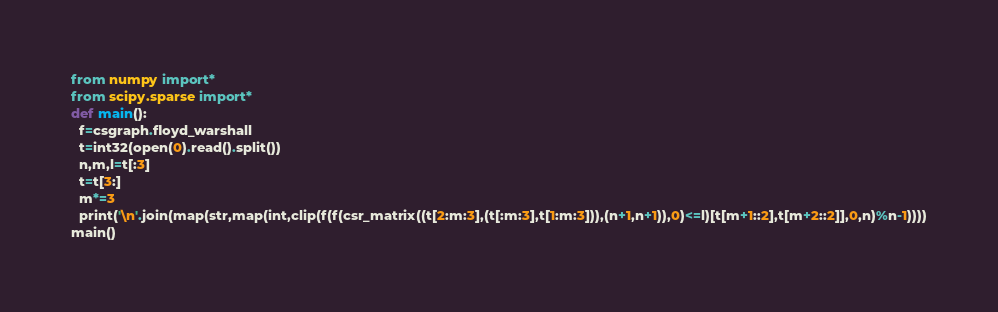Convert code to text. <code><loc_0><loc_0><loc_500><loc_500><_Python_>from numpy import*
from scipy.sparse import*
def main():
  f=csgraph.floyd_warshall
  t=int32(open(0).read().split())
  n,m,l=t[:3]
  t=t[3:]
  m*=3
  print('\n'.join(map(str,map(int,clip(f(f(csr_matrix((t[2:m:3],(t[:m:3],t[1:m:3])),(n+1,n+1)),0)<=l)[t[m+1::2],t[m+2::2]],0,n)%n-1))))
main()</code> 